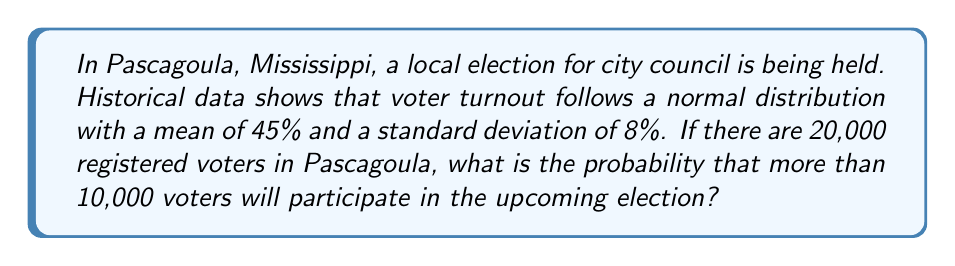Can you solve this math problem? Let's approach this step-by-step:

1) First, we need to convert the problem into a standardized normal distribution (z-score).

2) We know:
   - Mean (μ) = 45% of 20,000 = 9,000 voters
   - Standard deviation (σ) = 8% of 20,000 = 1,600 voters
   - We want to find P(X > 10,000)

3) Calculate the z-score:
   $$z = \frac{X - \mu}{\sigma} = \frac{10,000 - 9,000}{1,600} = \frac{1,000}{1,600} = 0.625$$

4) Now, we need to find P(Z > 0.625) using the standard normal distribution table.

5) From the table, we find that P(Z < 0.625) ≈ 0.7340

6) Since we want P(Z > 0.625), we calculate:
   P(Z > 0.625) = 1 - P(Z < 0.625) = 1 - 0.7340 = 0.2660

7) Therefore, the probability that more than 10,000 voters will participate is approximately 0.2660 or 26.60%.
Answer: 0.2660 